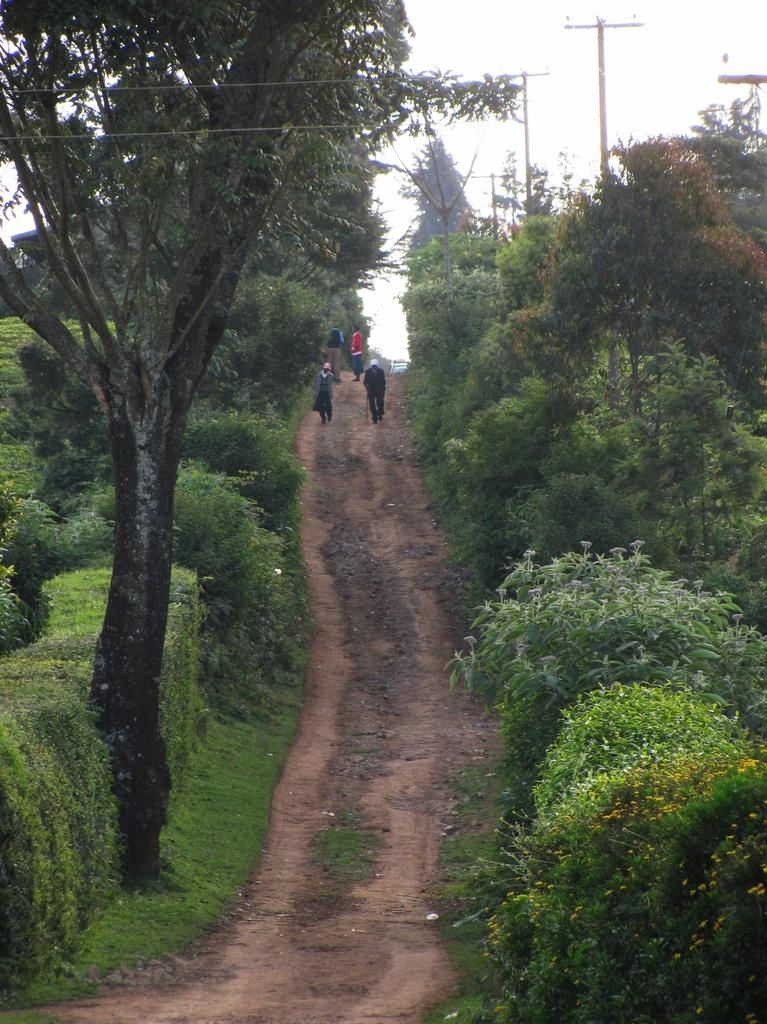What can be seen on the path in the image? There are people on the path in the image. What is present on both sides of the path? There are plants on both the right and left sides of the path in the image. What is visible in the background of the image? There are trees and poles in the background of the image. What type of flesh can be seen on the people in the image? There is no mention of flesh or any body parts in the image; it only shows people walking on a path surrounded by plants and trees. 